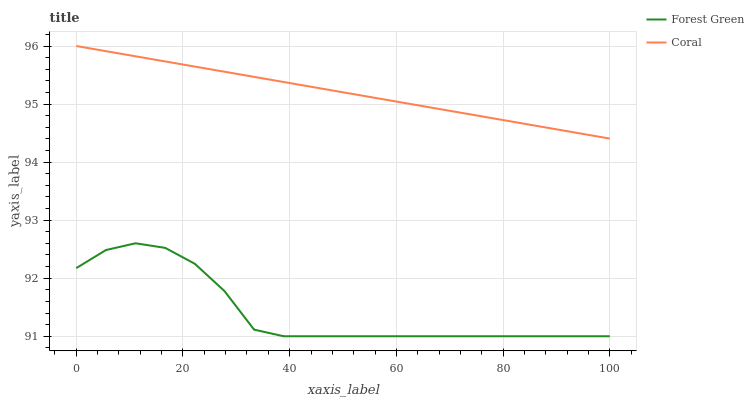Does Forest Green have the minimum area under the curve?
Answer yes or no. Yes. Does Coral have the maximum area under the curve?
Answer yes or no. Yes. Does Coral have the minimum area under the curve?
Answer yes or no. No. Is Coral the smoothest?
Answer yes or no. Yes. Is Forest Green the roughest?
Answer yes or no. Yes. Is Coral the roughest?
Answer yes or no. No. Does Forest Green have the lowest value?
Answer yes or no. Yes. Does Coral have the lowest value?
Answer yes or no. No. Does Coral have the highest value?
Answer yes or no. Yes. Is Forest Green less than Coral?
Answer yes or no. Yes. Is Coral greater than Forest Green?
Answer yes or no. Yes. Does Forest Green intersect Coral?
Answer yes or no. No. 